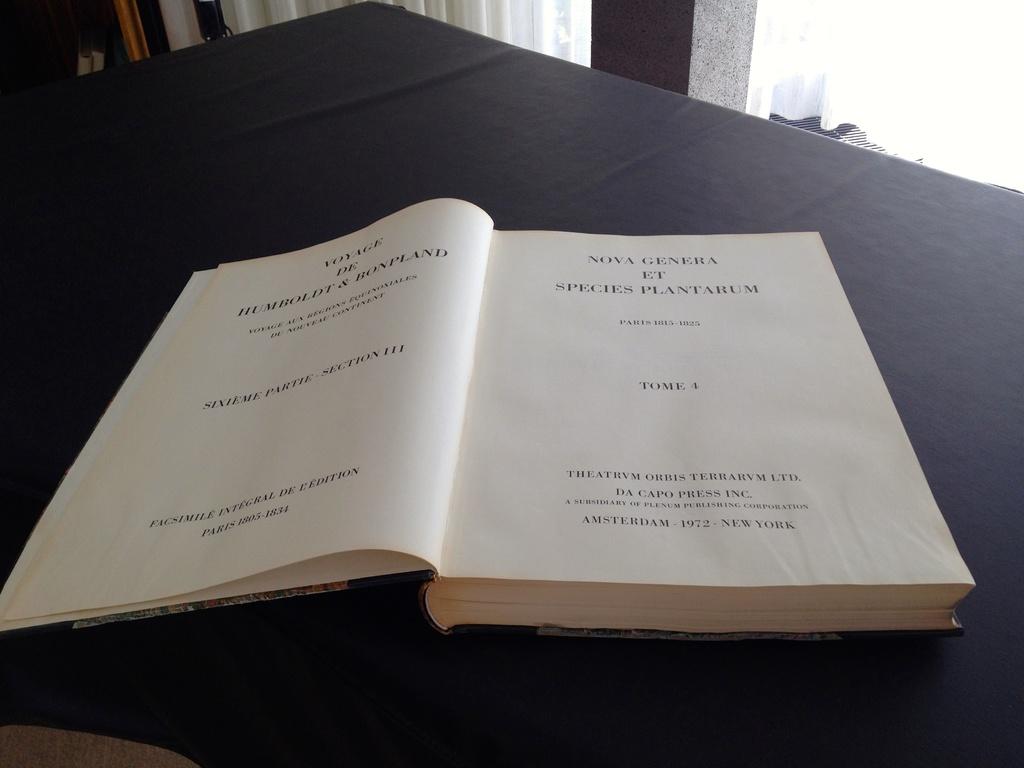What us city is cited at the bottom of the page?
Give a very brief answer. New york. 